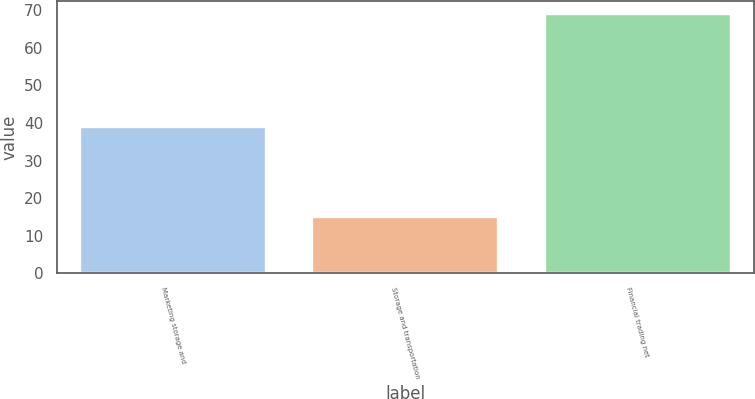<chart> <loc_0><loc_0><loc_500><loc_500><bar_chart><fcel>Marketing storage and<fcel>Storage and transportation<fcel>Financial trading net<nl><fcel>39<fcel>15<fcel>69<nl></chart> 